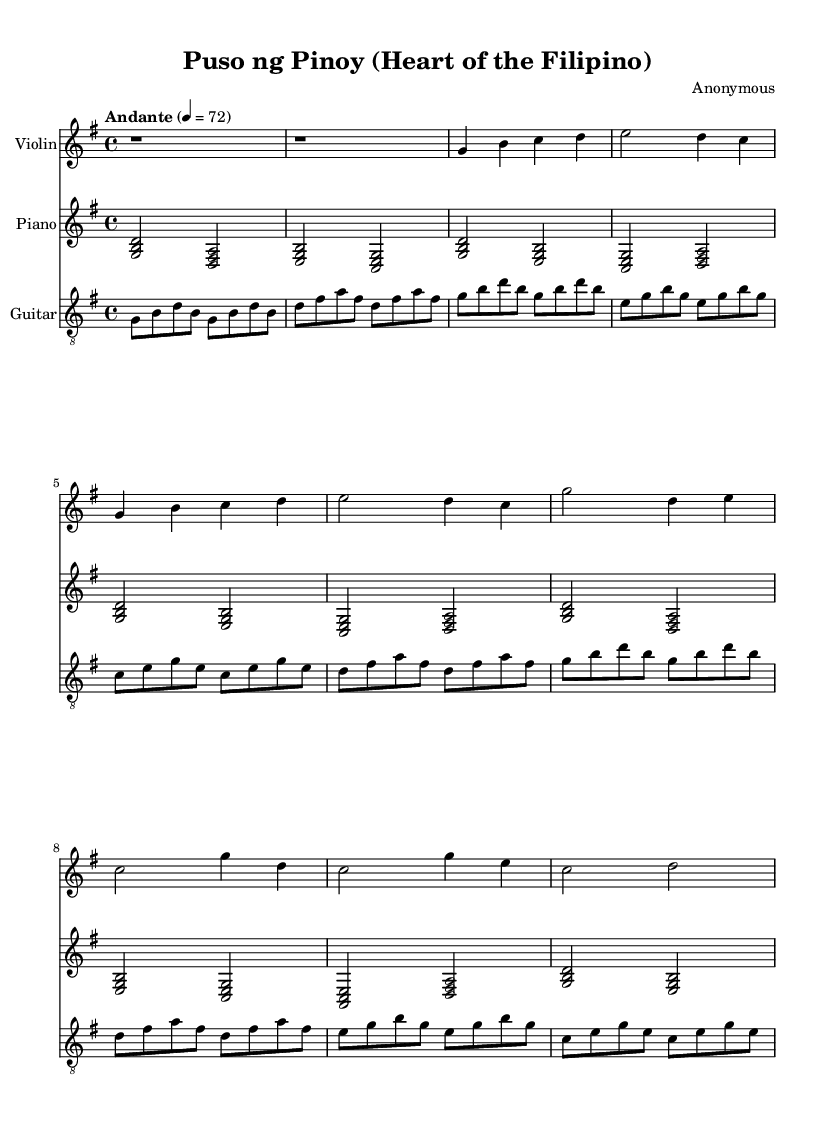What is the key signature of this music? The key signature is G major, which has one sharp (F#). This can be found by looking at the key signature indicated at the beginning of the music.
Answer: G major What is the time signature of this piece? The time signature is 4/4, as shown at the start of the music sheet. This means there are four beats per measure, and the quarter note gets one beat.
Answer: 4/4 What is the tempo marking for this piece? The tempo marking is "Andante," which means at a walking pace. This is indicated at the beginning of the score along with the metronome marking of 72 beats per minute.
Answer: Andante How many measures are in the verse section? The verse section consists of two measures, as counted from the introduction to the end of the section where the chord pattern repeats.
Answer: 2 What instruments are featured in this arrangement? The featured instruments are the Violin, Piano, and Guitar, as indicated in the score layout with separate staves for each instrument.
Answer: Violin, Piano, Guitar Which musical section follows the introduction? The section that follows the introduction is the Verse, as indicated by the absence of any specific marking for another section and the typical structure of songs to show the verse after the intro.
Answer: Verse How is the chorus different from the verse in terms of melody? The chorus has a different melodic pattern that elevates the emotional expression compared to the verse. The specific notes indicate a shift that is typical in Latin ballads to evoke stronger feelings.
Answer: Melodic shift 